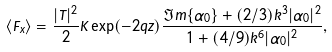<formula> <loc_0><loc_0><loc_500><loc_500>\langle F _ { x } \rangle = \frac { | T | ^ { 2 } } { 2 } K \exp ( - 2 q z ) \frac { \Im m \{ \alpha _ { 0 } \} + ( 2 / 3 ) k ^ { 3 } | \alpha _ { 0 } | ^ { 2 } } { 1 + ( 4 / 9 ) k ^ { 6 } | \alpha _ { 0 } | ^ { 2 } } ,</formula> 